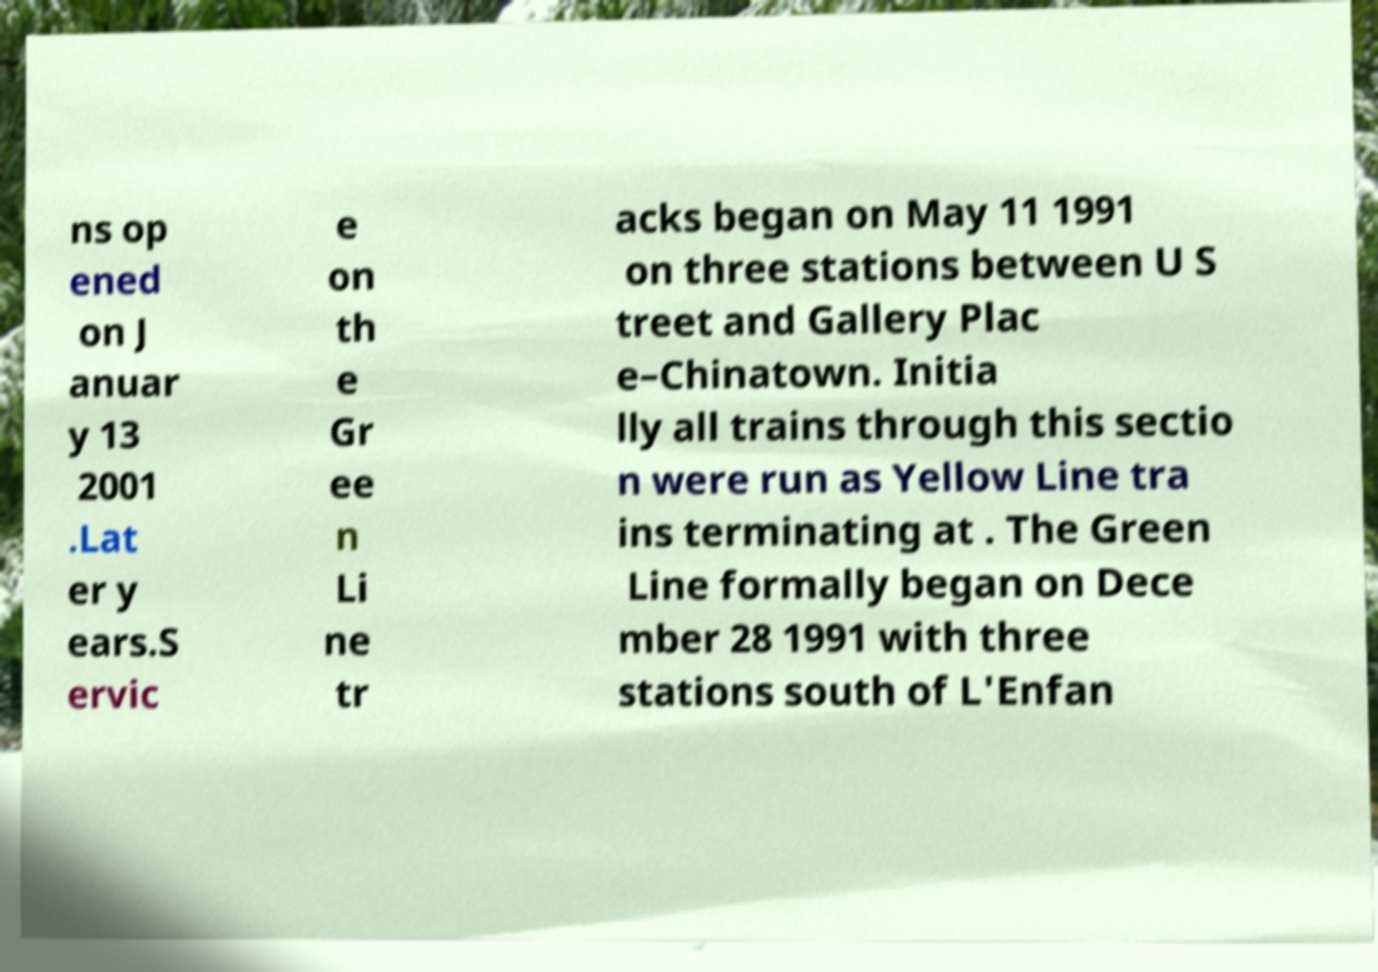Can you accurately transcribe the text from the provided image for me? ns op ened on J anuar y 13 2001 .Lat er y ears.S ervic e on th e Gr ee n Li ne tr acks began on May 11 1991 on three stations between U S treet and Gallery Plac e–Chinatown. Initia lly all trains through this sectio n were run as Yellow Line tra ins terminating at . The Green Line formally began on Dece mber 28 1991 with three stations south of L'Enfan 